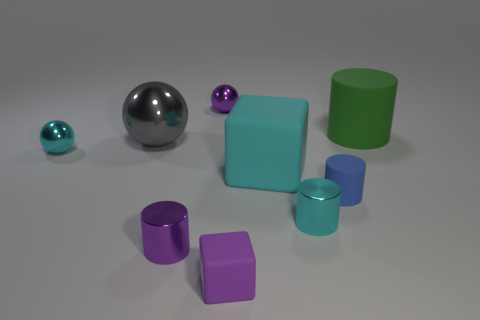There is a tiny matte cube; is its color the same as the small metal cylinder left of the large cyan matte cube?
Keep it short and to the point. Yes. Are there any tiny shiny spheres that have the same color as the big rubber cube?
Keep it short and to the point. Yes. What number of objects are tiny blue matte spheres or large matte things?
Provide a succinct answer. 2. Does the big metallic object have the same color as the tiny matte cylinder?
Your answer should be very brief. No. The big matte thing in front of the rubber cylinder that is behind the large cyan block is what shape?
Offer a very short reply. Cube. Are there fewer large balls than big brown metallic things?
Offer a terse response. No. What is the size of the thing that is to the right of the tiny purple ball and behind the cyan rubber block?
Provide a short and direct response. Large. Do the cyan shiny cylinder and the green matte cylinder have the same size?
Ensure brevity in your answer.  No. Is the color of the small object that is left of the small purple shiny cylinder the same as the big block?
Provide a succinct answer. Yes. There is a tiny cyan cylinder; what number of small shiny cylinders are to the left of it?
Your answer should be compact. 1. 